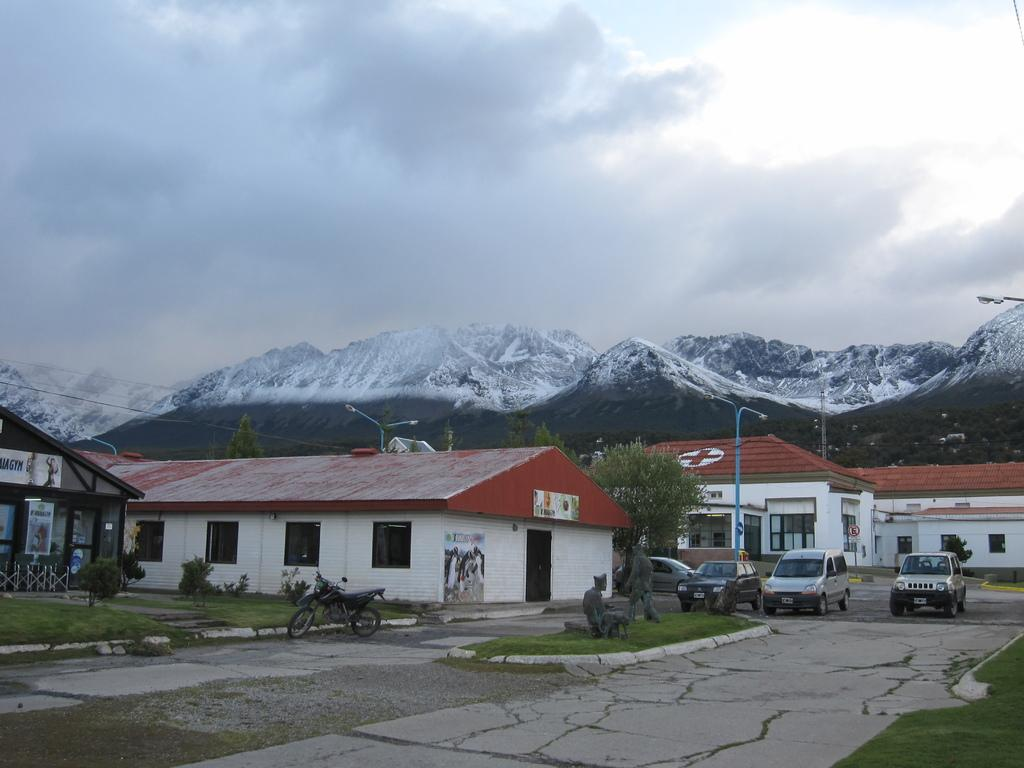What is located in the center of the image? Buildings, street lights, trees, plants, cars, sculptures, grass, and a road are located in the center of the image. What type of vehicles can be seen in the image? Cars and a motorbike are visible in the image. What is the condition of the sky in the image? The sky is cloudy in the image. What can be seen in the background of the image? Mountains are visible in the background of the image. What type of thought can be seen in the image? There is no thought present in the image; it is a visual representation of a scene. Can you see any bananas in the image? There are no bananas present in the image. 